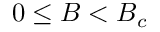<formula> <loc_0><loc_0><loc_500><loc_500>0 \leq B < B _ { c }</formula> 